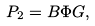Convert formula to latex. <formula><loc_0><loc_0><loc_500><loc_500>P _ { 2 } = B \Phi G ,</formula> 